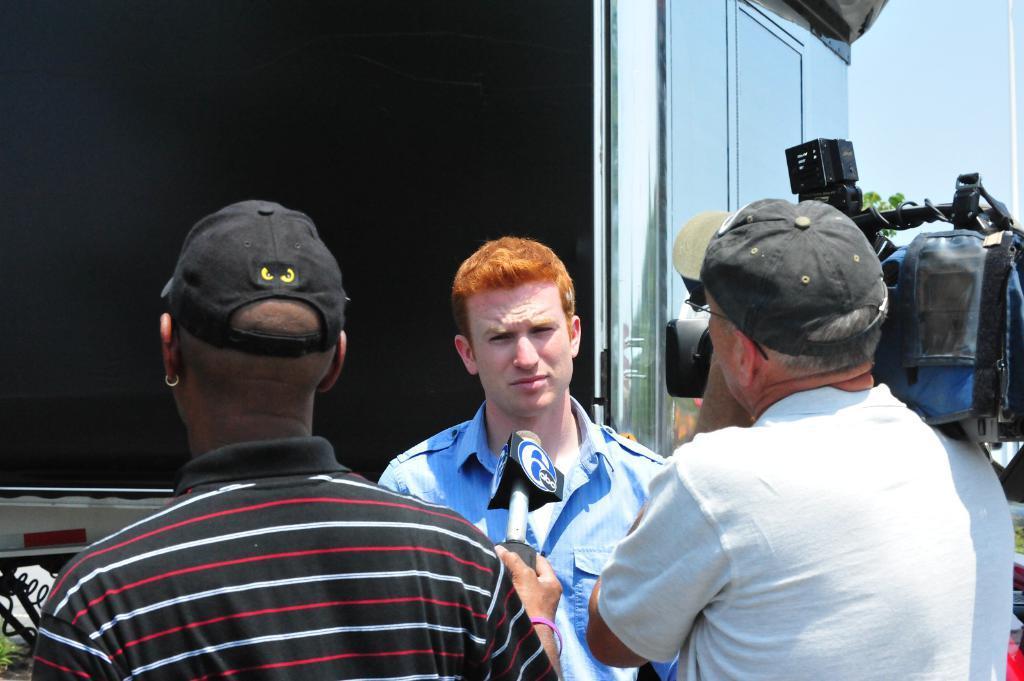In one or two sentences, can you explain what this image depicts? In this image we can see a few people and one person among them is carrying a camera and another person is holding a mic. In the background, there is an object which looks like a house. 